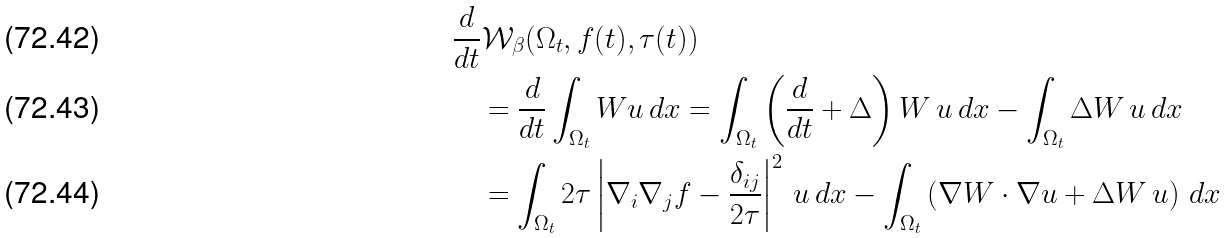<formula> <loc_0><loc_0><loc_500><loc_500>& \frac { d } { d t } \mathcal { W } _ { \beta } ( \Omega _ { t } , f ( t ) , \tau ( t ) ) \\ & \quad = \frac { d } { d t } \int _ { \Omega _ { t } } W u \, d x = \int _ { \Omega _ { t } } \left ( \frac { d } { d t } + \Delta \right ) W \, u \, d x - \int _ { \Omega _ { t } } \Delta W \, u \, d x \\ & \quad = \int _ { \Omega _ { t } } 2 \tau \left | \nabla _ { i } \nabla _ { j } f - \frac { \delta _ { i j } } { 2 \tau } \right | ^ { 2 } \, u \, d x - \int _ { \Omega _ { t } } \left ( \nabla W \cdot \nabla u + \Delta W \, u \right ) \, d x</formula> 